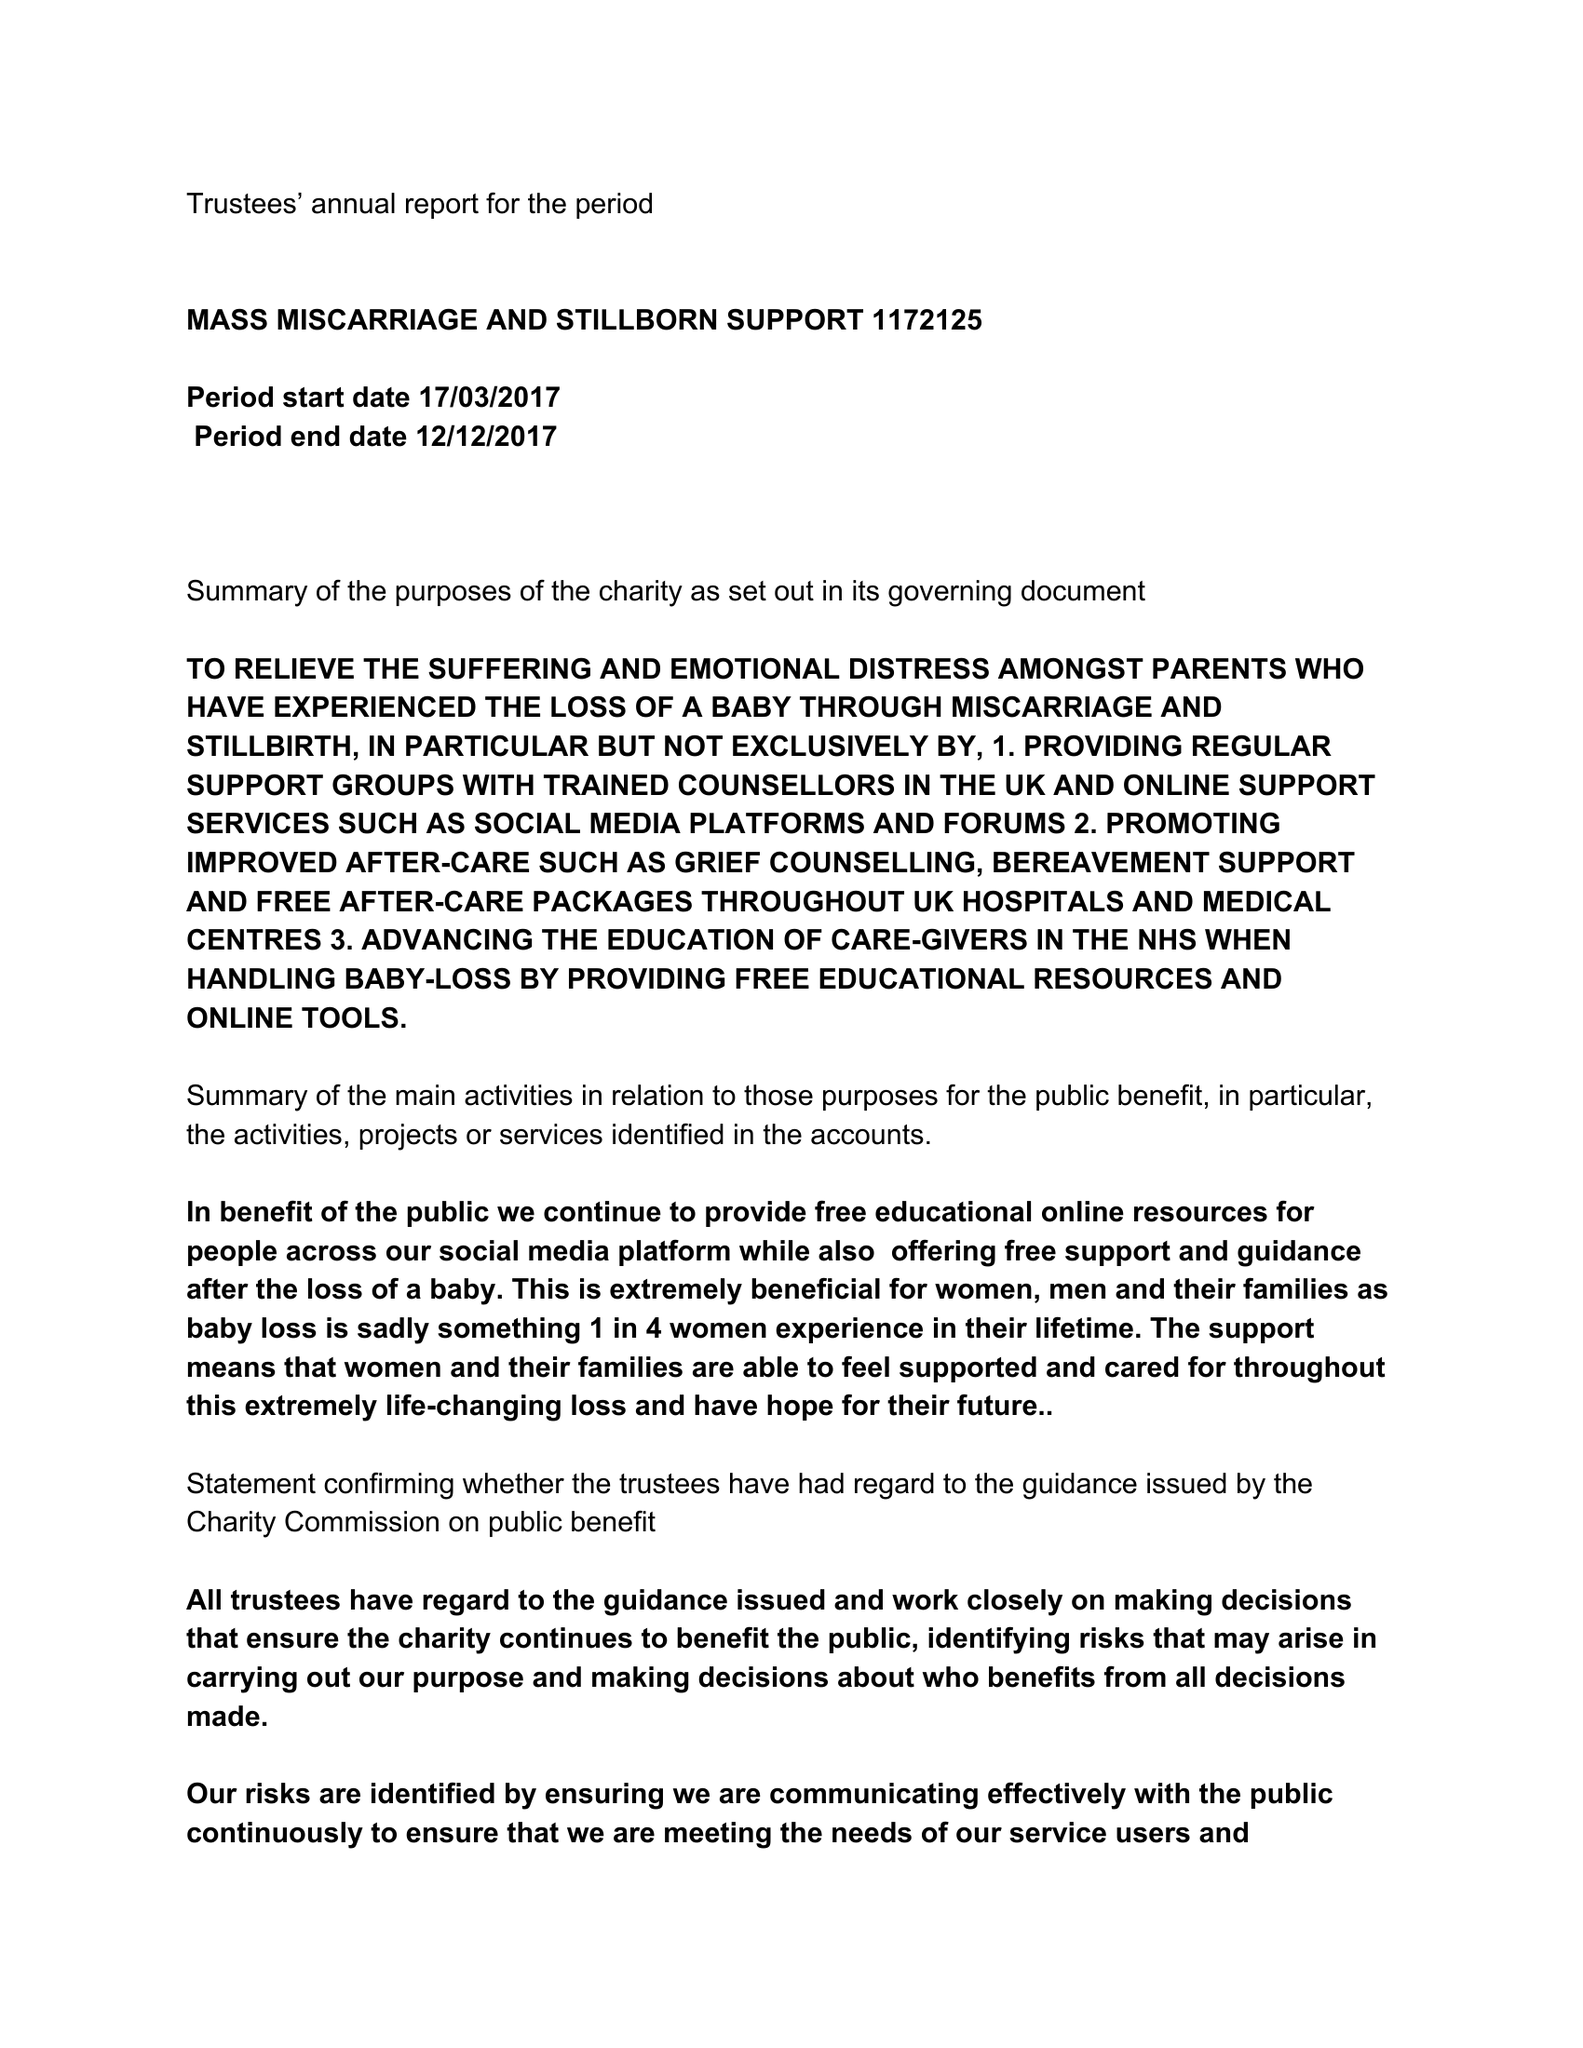What is the value for the address__street_line?
Answer the question using a single word or phrase. 2 NICHOLLS ROAD 